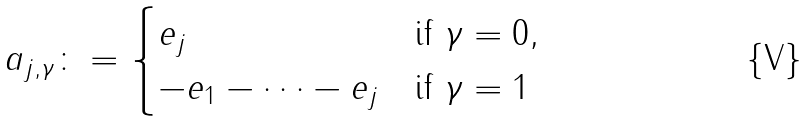<formula> <loc_0><loc_0><loc_500><loc_500>a _ { j , \gamma } \colon = \begin{cases} e _ { j } & \text {if $\gamma=0$} , \\ - e _ { 1 } - \dots - e _ { j } & \text {if $\gamma=1$} \end{cases}</formula> 